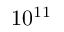<formula> <loc_0><loc_0><loc_500><loc_500>1 0 ^ { 1 1 }</formula> 